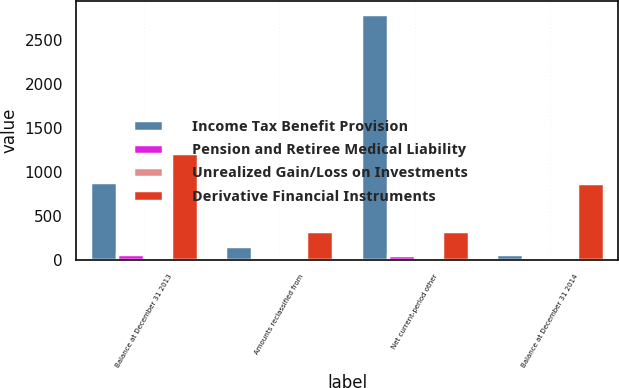<chart> <loc_0><loc_0><loc_500><loc_500><stacked_bar_chart><ecel><fcel>Balance at December 31 2013<fcel>Amounts reclassified from<fcel>Net current-period other<fcel>Balance at December 31 2014<nl><fcel>Income Tax Benefit Provision<fcel>887<fcel>163<fcel>2796<fcel>67<nl><fcel>Pension and Retiree Medical Liability<fcel>67<fcel>4<fcel>58<fcel>9<nl><fcel>Unrealized Gain/Loss on Investments<fcel>2<fcel>3<fcel>3<fcel>5<nl><fcel>Derivative Financial Instruments<fcel>1210<fcel>330<fcel>330<fcel>880<nl></chart> 